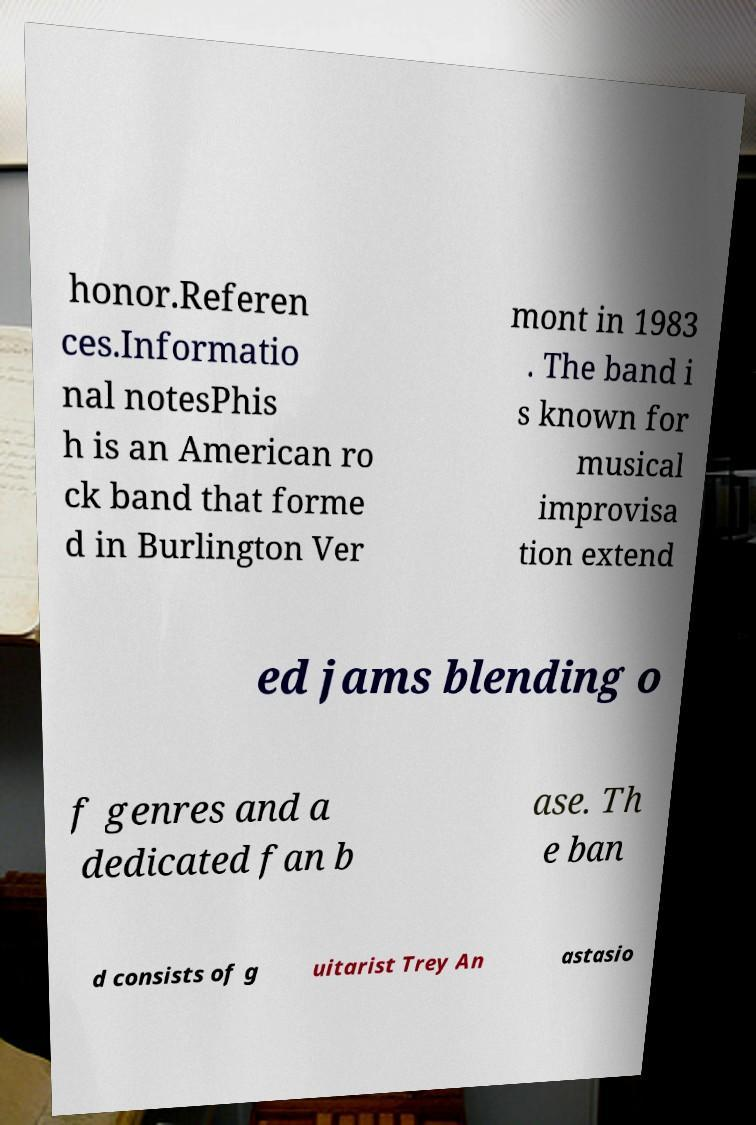Please identify and transcribe the text found in this image. honor.Referen ces.Informatio nal notesPhis h is an American ro ck band that forme d in Burlington Ver mont in 1983 . The band i s known for musical improvisa tion extend ed jams blending o f genres and a dedicated fan b ase. Th e ban d consists of g uitarist Trey An astasio 